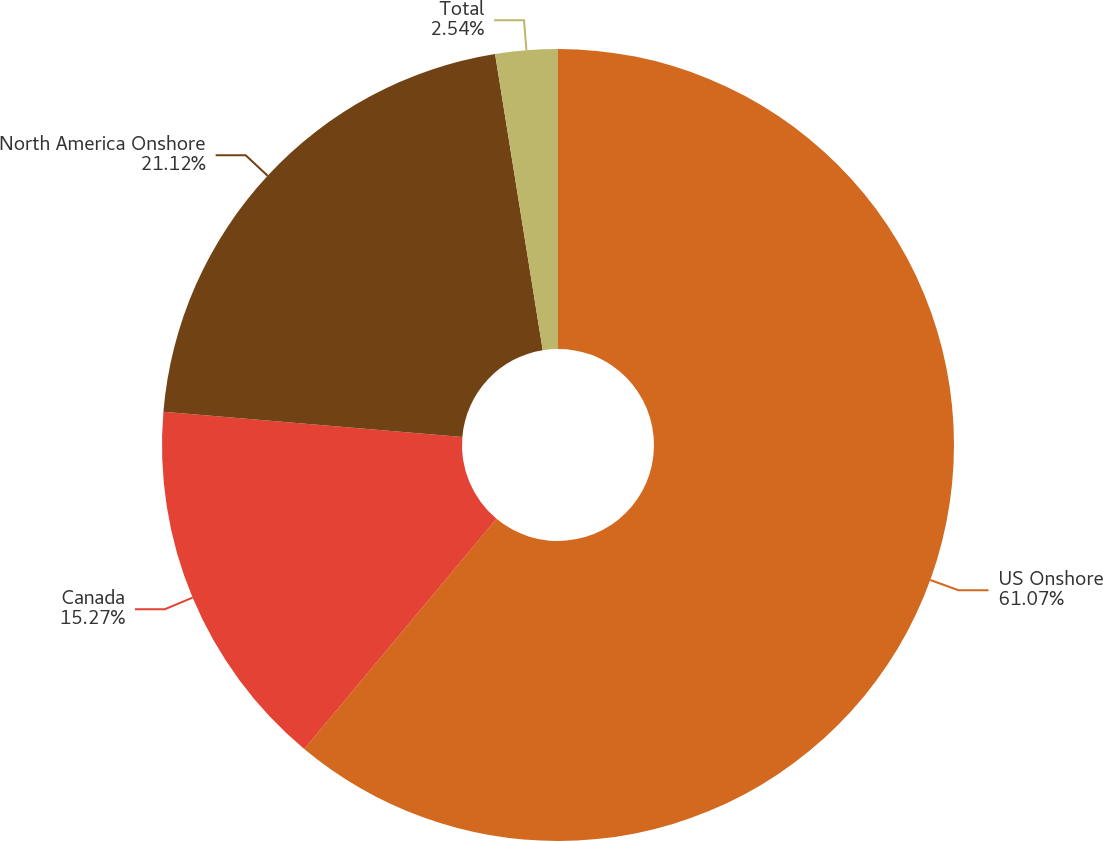<chart> <loc_0><loc_0><loc_500><loc_500><pie_chart><fcel>US Onshore<fcel>Canada<fcel>North America Onshore<fcel>Total<nl><fcel>61.07%<fcel>15.27%<fcel>21.12%<fcel>2.54%<nl></chart> 